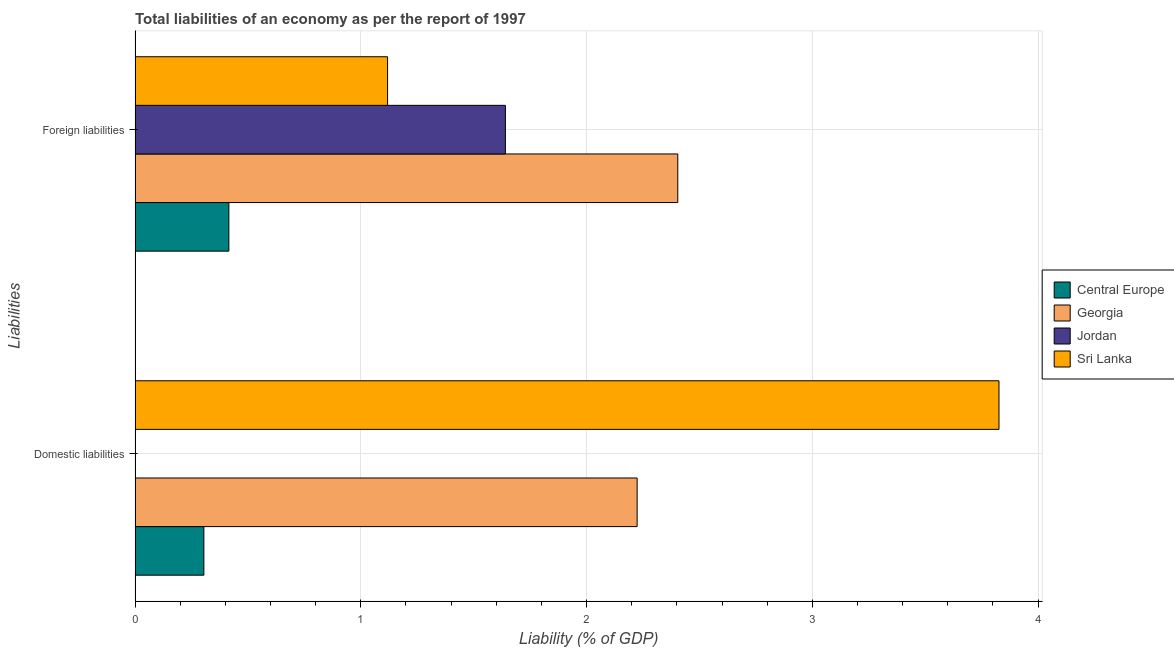How many different coloured bars are there?
Make the answer very short. 4. How many bars are there on the 2nd tick from the bottom?
Offer a very short reply. 4. What is the label of the 2nd group of bars from the top?
Offer a terse response. Domestic liabilities. What is the incurrence of domestic liabilities in Georgia?
Your response must be concise. 2.22. Across all countries, what is the maximum incurrence of foreign liabilities?
Your answer should be very brief. 2.4. Across all countries, what is the minimum incurrence of foreign liabilities?
Keep it short and to the point. 0.42. In which country was the incurrence of foreign liabilities maximum?
Offer a very short reply. Georgia. What is the total incurrence of domestic liabilities in the graph?
Keep it short and to the point. 6.36. What is the difference between the incurrence of domestic liabilities in Sri Lanka and that in Georgia?
Keep it short and to the point. 1.6. What is the difference between the incurrence of foreign liabilities in Central Europe and the incurrence of domestic liabilities in Sri Lanka?
Your response must be concise. -3.41. What is the average incurrence of domestic liabilities per country?
Give a very brief answer. 1.59. What is the difference between the incurrence of domestic liabilities and incurrence of foreign liabilities in Georgia?
Your answer should be compact. -0.18. In how many countries, is the incurrence of foreign liabilities greater than 3.6 %?
Give a very brief answer. 0. What is the ratio of the incurrence of foreign liabilities in Jordan to that in Georgia?
Offer a terse response. 0.68. How many bars are there?
Your answer should be very brief. 7. How many legend labels are there?
Offer a terse response. 4. What is the title of the graph?
Keep it short and to the point. Total liabilities of an economy as per the report of 1997. What is the label or title of the X-axis?
Keep it short and to the point. Liability (% of GDP). What is the label or title of the Y-axis?
Your response must be concise. Liabilities. What is the Liability (% of GDP) of Central Europe in Domestic liabilities?
Ensure brevity in your answer.  0.3. What is the Liability (% of GDP) in Georgia in Domestic liabilities?
Ensure brevity in your answer.  2.22. What is the Liability (% of GDP) in Sri Lanka in Domestic liabilities?
Your answer should be very brief. 3.83. What is the Liability (% of GDP) of Central Europe in Foreign liabilities?
Offer a terse response. 0.42. What is the Liability (% of GDP) of Georgia in Foreign liabilities?
Offer a very short reply. 2.4. What is the Liability (% of GDP) of Jordan in Foreign liabilities?
Give a very brief answer. 1.64. What is the Liability (% of GDP) in Sri Lanka in Foreign liabilities?
Keep it short and to the point. 1.12. Across all Liabilities, what is the maximum Liability (% of GDP) in Central Europe?
Provide a short and direct response. 0.42. Across all Liabilities, what is the maximum Liability (% of GDP) of Georgia?
Provide a succinct answer. 2.4. Across all Liabilities, what is the maximum Liability (% of GDP) in Jordan?
Your answer should be very brief. 1.64. Across all Liabilities, what is the maximum Liability (% of GDP) in Sri Lanka?
Ensure brevity in your answer.  3.83. Across all Liabilities, what is the minimum Liability (% of GDP) of Central Europe?
Give a very brief answer. 0.3. Across all Liabilities, what is the minimum Liability (% of GDP) in Georgia?
Provide a succinct answer. 2.22. Across all Liabilities, what is the minimum Liability (% of GDP) in Jordan?
Your answer should be very brief. 0. Across all Liabilities, what is the minimum Liability (% of GDP) in Sri Lanka?
Ensure brevity in your answer.  1.12. What is the total Liability (% of GDP) of Central Europe in the graph?
Your answer should be compact. 0.72. What is the total Liability (% of GDP) in Georgia in the graph?
Make the answer very short. 4.63. What is the total Liability (% of GDP) in Jordan in the graph?
Your answer should be very brief. 1.64. What is the total Liability (% of GDP) of Sri Lanka in the graph?
Your answer should be compact. 4.95. What is the difference between the Liability (% of GDP) of Central Europe in Domestic liabilities and that in Foreign liabilities?
Provide a succinct answer. -0.11. What is the difference between the Liability (% of GDP) of Georgia in Domestic liabilities and that in Foreign liabilities?
Give a very brief answer. -0.18. What is the difference between the Liability (% of GDP) of Sri Lanka in Domestic liabilities and that in Foreign liabilities?
Make the answer very short. 2.71. What is the difference between the Liability (% of GDP) of Central Europe in Domestic liabilities and the Liability (% of GDP) of Georgia in Foreign liabilities?
Provide a succinct answer. -2.1. What is the difference between the Liability (% of GDP) of Central Europe in Domestic liabilities and the Liability (% of GDP) of Jordan in Foreign liabilities?
Offer a terse response. -1.34. What is the difference between the Liability (% of GDP) in Central Europe in Domestic liabilities and the Liability (% of GDP) in Sri Lanka in Foreign liabilities?
Give a very brief answer. -0.81. What is the difference between the Liability (% of GDP) in Georgia in Domestic liabilities and the Liability (% of GDP) in Jordan in Foreign liabilities?
Give a very brief answer. 0.58. What is the difference between the Liability (% of GDP) of Georgia in Domestic liabilities and the Liability (% of GDP) of Sri Lanka in Foreign liabilities?
Make the answer very short. 1.11. What is the average Liability (% of GDP) of Central Europe per Liabilities?
Offer a terse response. 0.36. What is the average Liability (% of GDP) of Georgia per Liabilities?
Offer a very short reply. 2.31. What is the average Liability (% of GDP) in Jordan per Liabilities?
Your response must be concise. 0.82. What is the average Liability (% of GDP) of Sri Lanka per Liabilities?
Ensure brevity in your answer.  2.47. What is the difference between the Liability (% of GDP) in Central Europe and Liability (% of GDP) in Georgia in Domestic liabilities?
Your answer should be compact. -1.92. What is the difference between the Liability (% of GDP) in Central Europe and Liability (% of GDP) in Sri Lanka in Domestic liabilities?
Ensure brevity in your answer.  -3.52. What is the difference between the Liability (% of GDP) in Georgia and Liability (% of GDP) in Sri Lanka in Domestic liabilities?
Your answer should be compact. -1.6. What is the difference between the Liability (% of GDP) of Central Europe and Liability (% of GDP) of Georgia in Foreign liabilities?
Your response must be concise. -1.99. What is the difference between the Liability (% of GDP) of Central Europe and Liability (% of GDP) of Jordan in Foreign liabilities?
Make the answer very short. -1.23. What is the difference between the Liability (% of GDP) in Central Europe and Liability (% of GDP) in Sri Lanka in Foreign liabilities?
Offer a very short reply. -0.7. What is the difference between the Liability (% of GDP) in Georgia and Liability (% of GDP) in Jordan in Foreign liabilities?
Keep it short and to the point. 0.76. What is the difference between the Liability (% of GDP) of Georgia and Liability (% of GDP) of Sri Lanka in Foreign liabilities?
Your answer should be compact. 1.29. What is the difference between the Liability (% of GDP) of Jordan and Liability (% of GDP) of Sri Lanka in Foreign liabilities?
Make the answer very short. 0.52. What is the ratio of the Liability (% of GDP) of Central Europe in Domestic liabilities to that in Foreign liabilities?
Ensure brevity in your answer.  0.73. What is the ratio of the Liability (% of GDP) of Georgia in Domestic liabilities to that in Foreign liabilities?
Offer a terse response. 0.93. What is the ratio of the Liability (% of GDP) of Sri Lanka in Domestic liabilities to that in Foreign liabilities?
Provide a succinct answer. 3.42. What is the difference between the highest and the second highest Liability (% of GDP) in Central Europe?
Keep it short and to the point. 0.11. What is the difference between the highest and the second highest Liability (% of GDP) of Georgia?
Provide a succinct answer. 0.18. What is the difference between the highest and the second highest Liability (% of GDP) of Sri Lanka?
Your answer should be compact. 2.71. What is the difference between the highest and the lowest Liability (% of GDP) of Central Europe?
Offer a terse response. 0.11. What is the difference between the highest and the lowest Liability (% of GDP) in Georgia?
Provide a short and direct response. 0.18. What is the difference between the highest and the lowest Liability (% of GDP) in Jordan?
Your answer should be compact. 1.64. What is the difference between the highest and the lowest Liability (% of GDP) of Sri Lanka?
Ensure brevity in your answer.  2.71. 